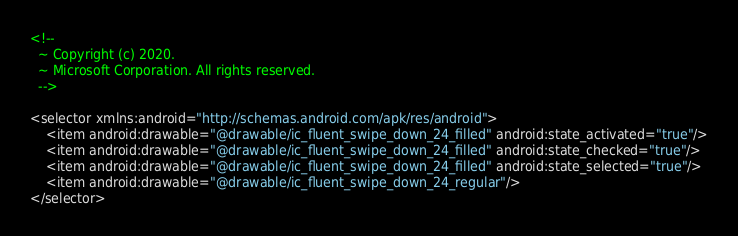Convert code to text. <code><loc_0><loc_0><loc_500><loc_500><_XML_><!--
  ~ Copyright (c) 2020.
  ~ Microsoft Corporation. All rights reserved.
  -->

<selector xmlns:android="http://schemas.android.com/apk/res/android">
    <item android:drawable="@drawable/ic_fluent_swipe_down_24_filled" android:state_activated="true"/>
    <item android:drawable="@drawable/ic_fluent_swipe_down_24_filled" android:state_checked="true"/>
    <item android:drawable="@drawable/ic_fluent_swipe_down_24_filled" android:state_selected="true"/>
    <item android:drawable="@drawable/ic_fluent_swipe_down_24_regular"/>
</selector>
</code> 